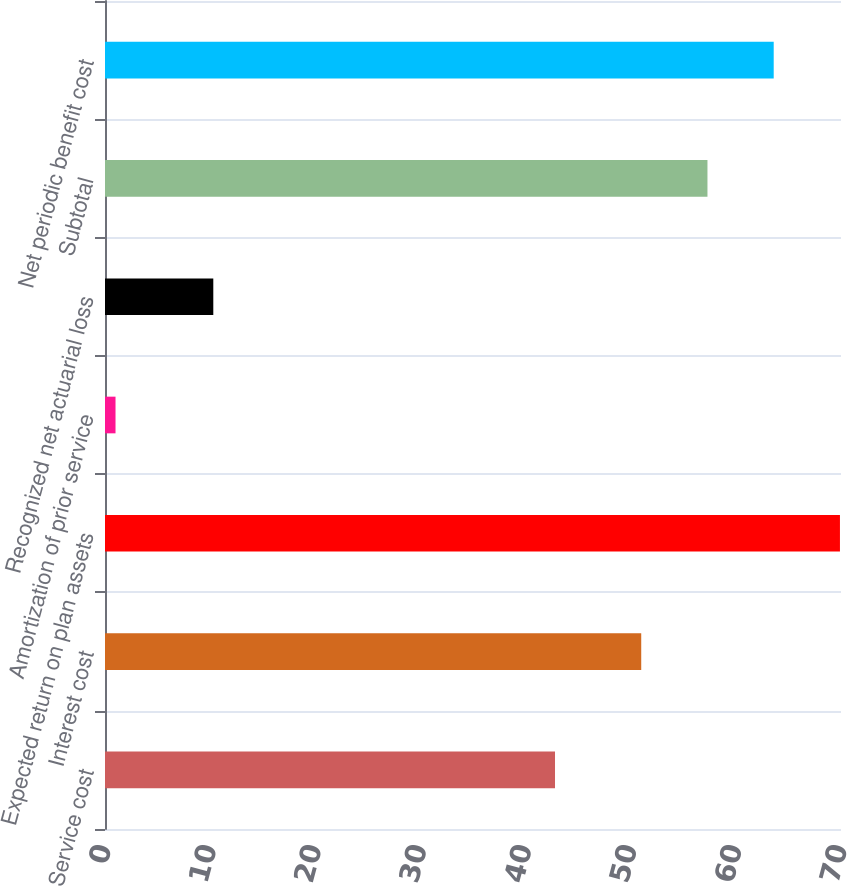Convert chart. <chart><loc_0><loc_0><loc_500><loc_500><bar_chart><fcel>Service cost<fcel>Interest cost<fcel>Expected return on plan assets<fcel>Amortization of prior service<fcel>Recognized net actuarial loss<fcel>Subtotal<fcel>Net periodic benefit cost<nl><fcel>42.8<fcel>51<fcel>69.9<fcel>1<fcel>10.3<fcel>57.3<fcel>63.6<nl></chart> 